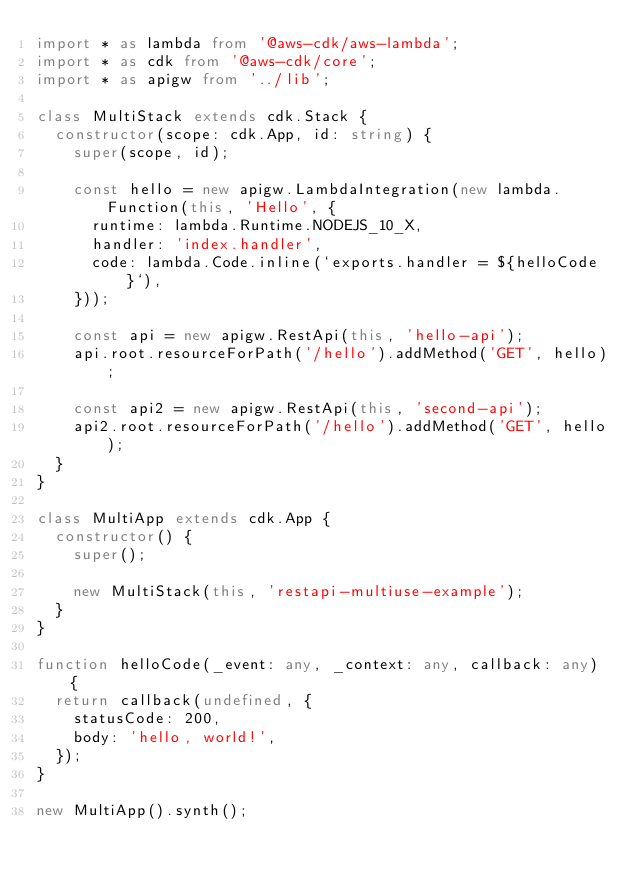<code> <loc_0><loc_0><loc_500><loc_500><_TypeScript_>import * as lambda from '@aws-cdk/aws-lambda';
import * as cdk from '@aws-cdk/core';
import * as apigw from '../lib';

class MultiStack extends cdk.Stack {
  constructor(scope: cdk.App, id: string) {
    super(scope, id);

    const hello = new apigw.LambdaIntegration(new lambda.Function(this, 'Hello', {
      runtime: lambda.Runtime.NODEJS_10_X,
      handler: 'index.handler',
      code: lambda.Code.inline(`exports.handler = ${helloCode}`),
    }));

    const api = new apigw.RestApi(this, 'hello-api');
    api.root.resourceForPath('/hello').addMethod('GET', hello);

    const api2 = new apigw.RestApi(this, 'second-api');
    api2.root.resourceForPath('/hello').addMethod('GET', hello);
  }
}

class MultiApp extends cdk.App {
  constructor() {
    super();

    new MultiStack(this, 'restapi-multiuse-example');
  }
}

function helloCode(_event: any, _context: any, callback: any) {
  return callback(undefined, {
    statusCode: 200,
    body: 'hello, world!',
  });
}

new MultiApp().synth();
</code> 